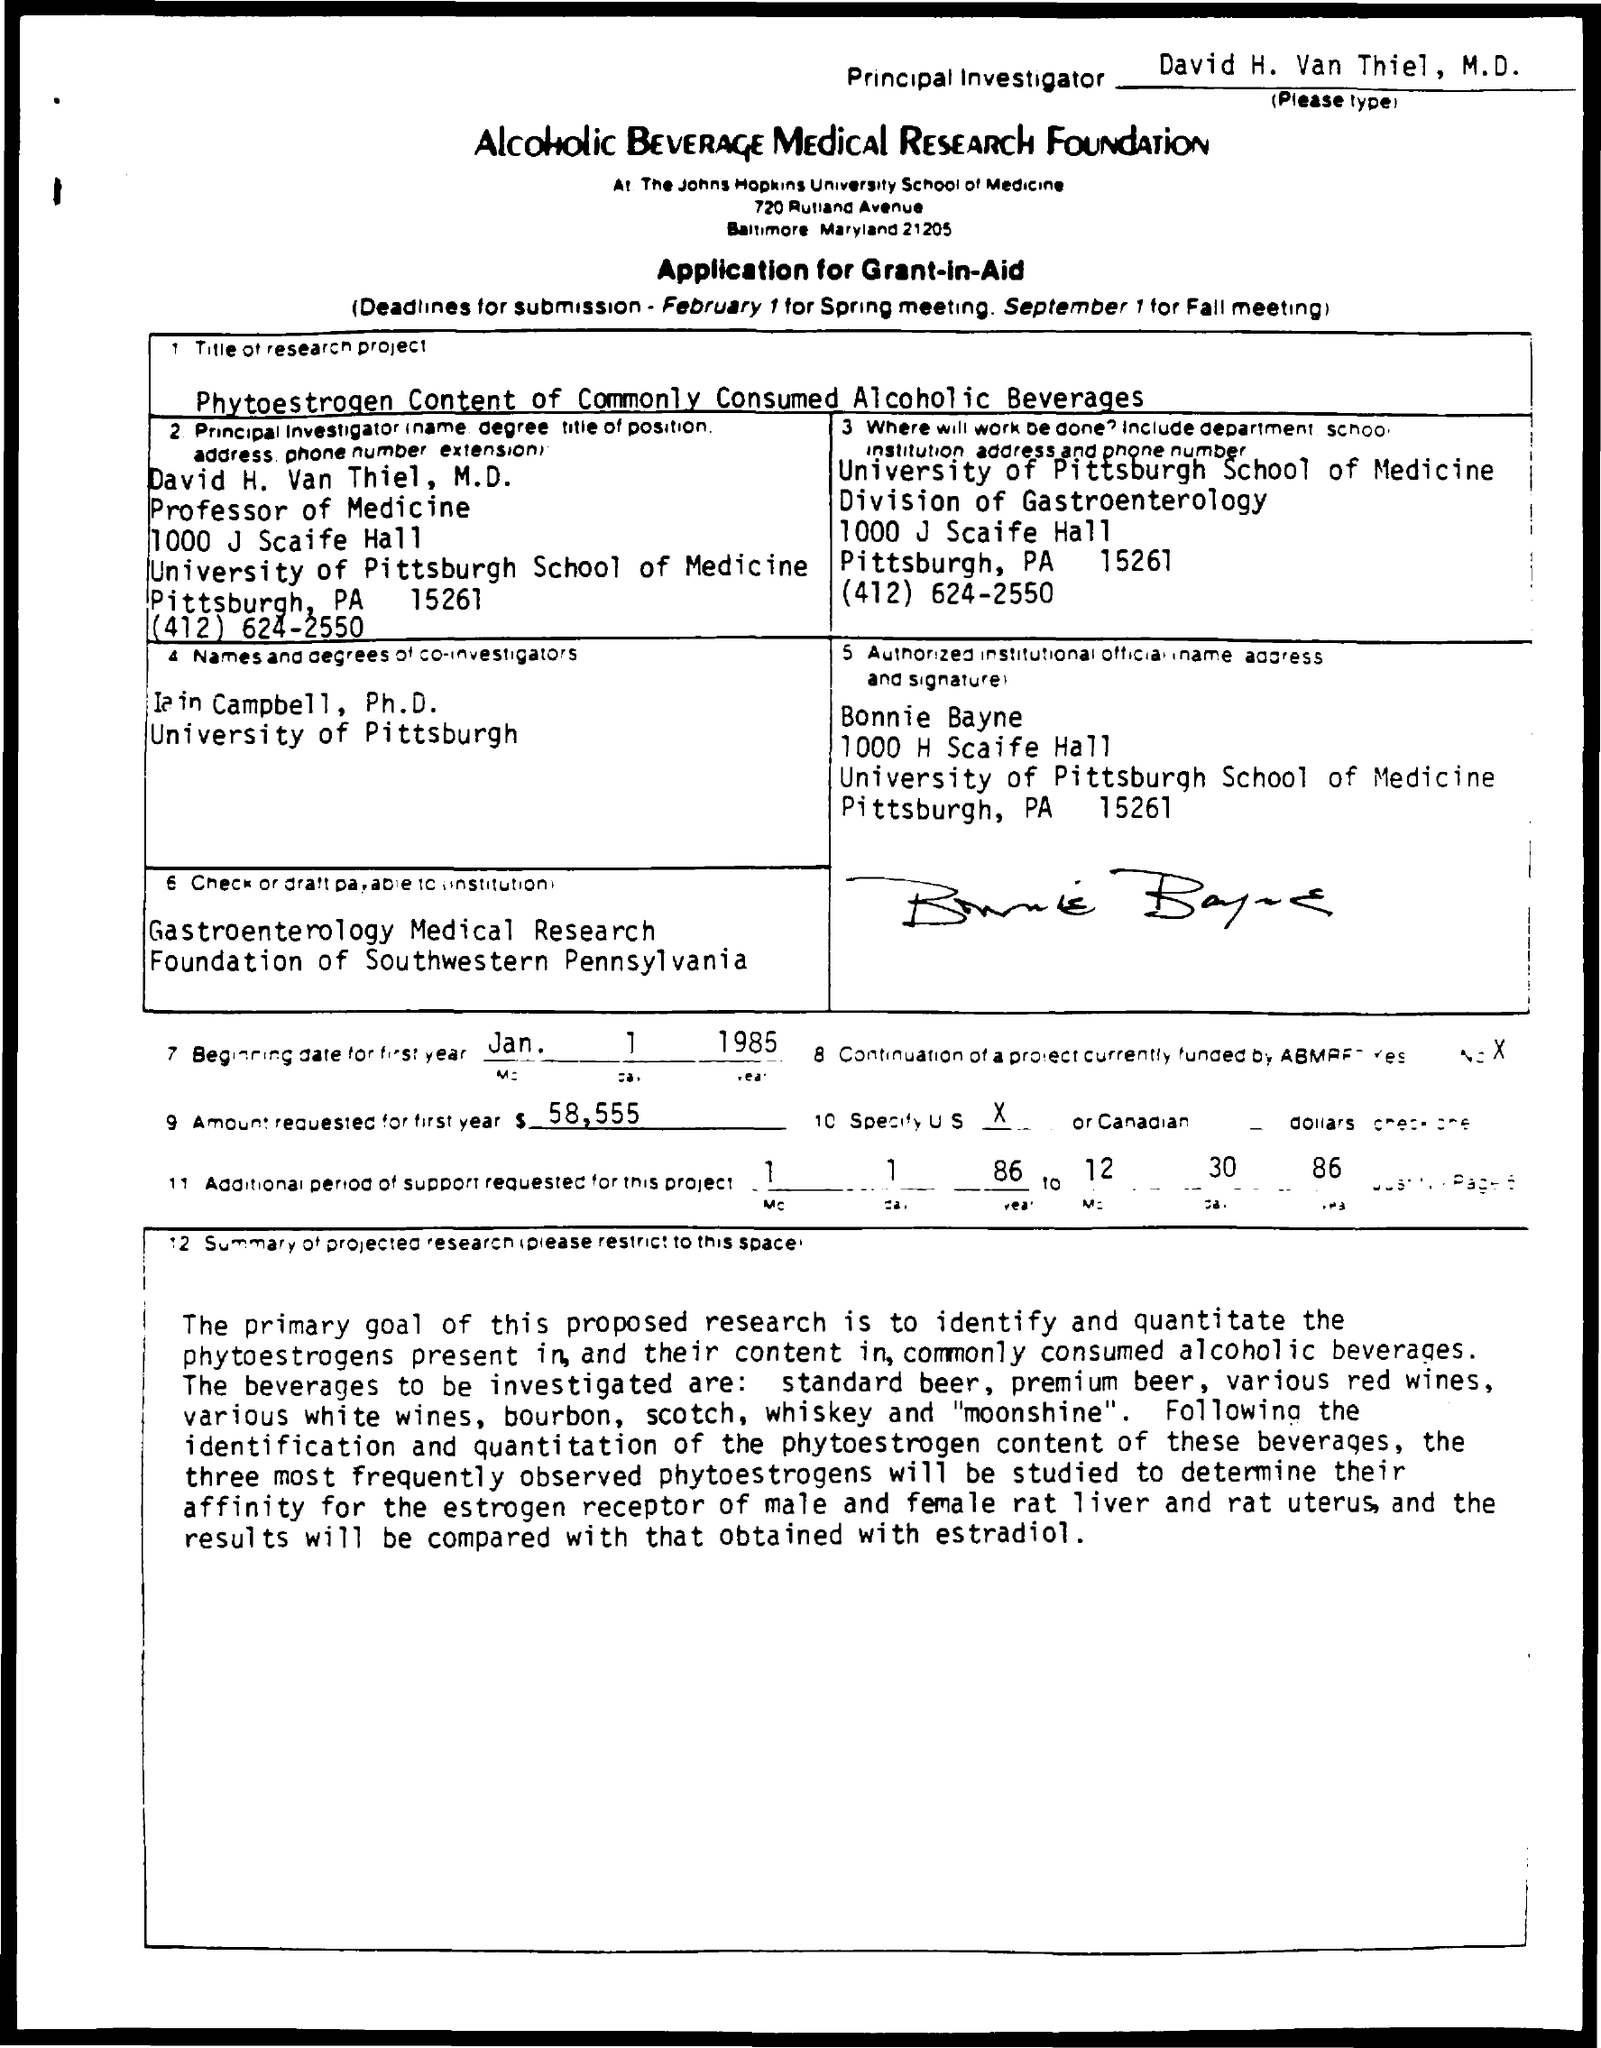Mention a couple of crucial points in this snapshot. The Principal Investigator is David H. Van Thiel, M.D. The amount requested for the first year is $58,555. The beginning date for the first year was January 1, 1985. 